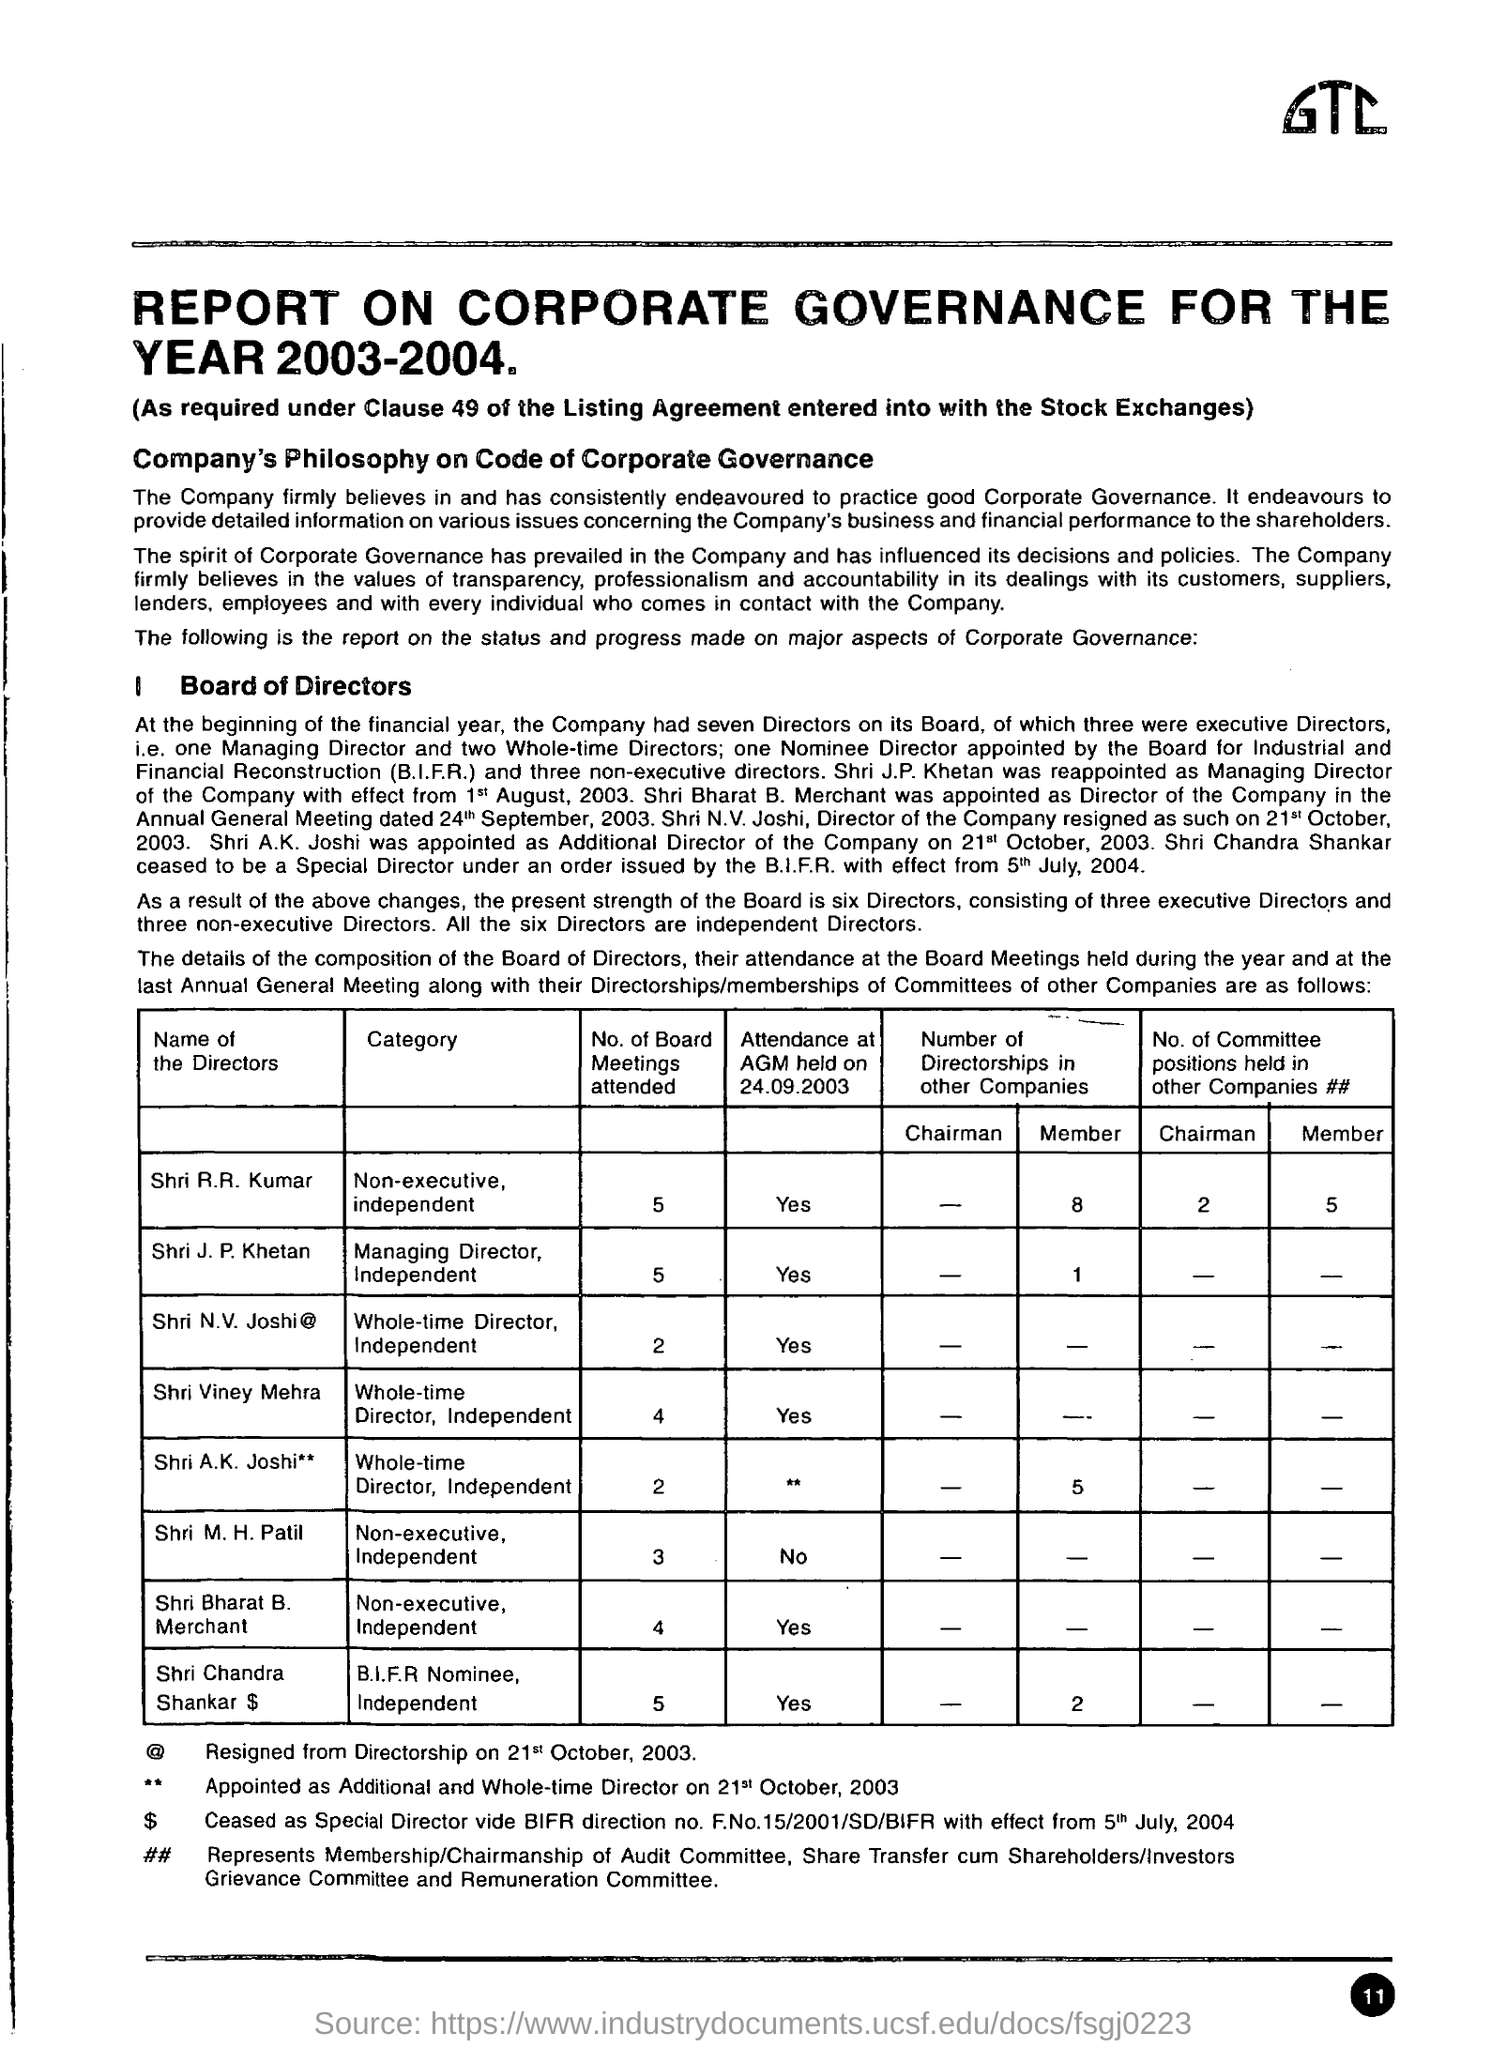Can you tell me about the changes in the director board that occurred during the year? Certainly! Throughout the financial year, there were several changes within the board of directors. Shri Bharat B. Merchant was appointed as a Director of the company, and Shri N.V. Joshi resigned. Additionally, Shri A.K. Joshi joined as an Additional Director during the year. These shifts resulted in a board composition consisting of six directors by the end of the financial year. 